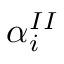Convert formula to latex. <formula><loc_0><loc_0><loc_500><loc_500>\alpha _ { i } ^ { I I }</formula> 